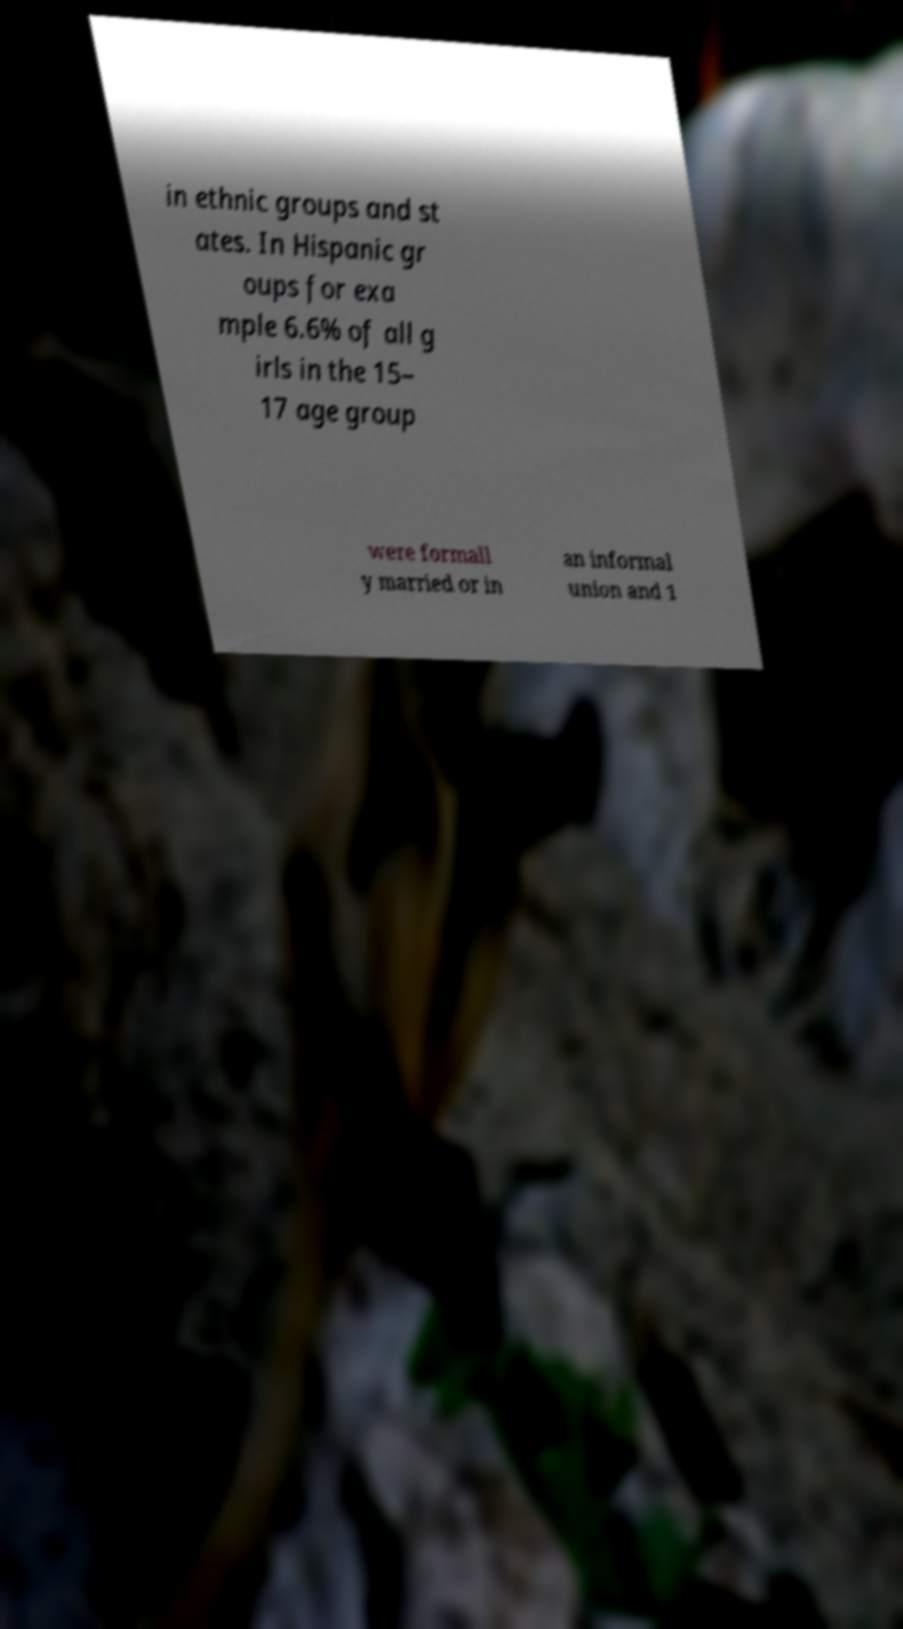Can you accurately transcribe the text from the provided image for me? in ethnic groups and st ates. In Hispanic gr oups for exa mple 6.6% of all g irls in the 15– 17 age group were formall y married or in an informal union and 1 